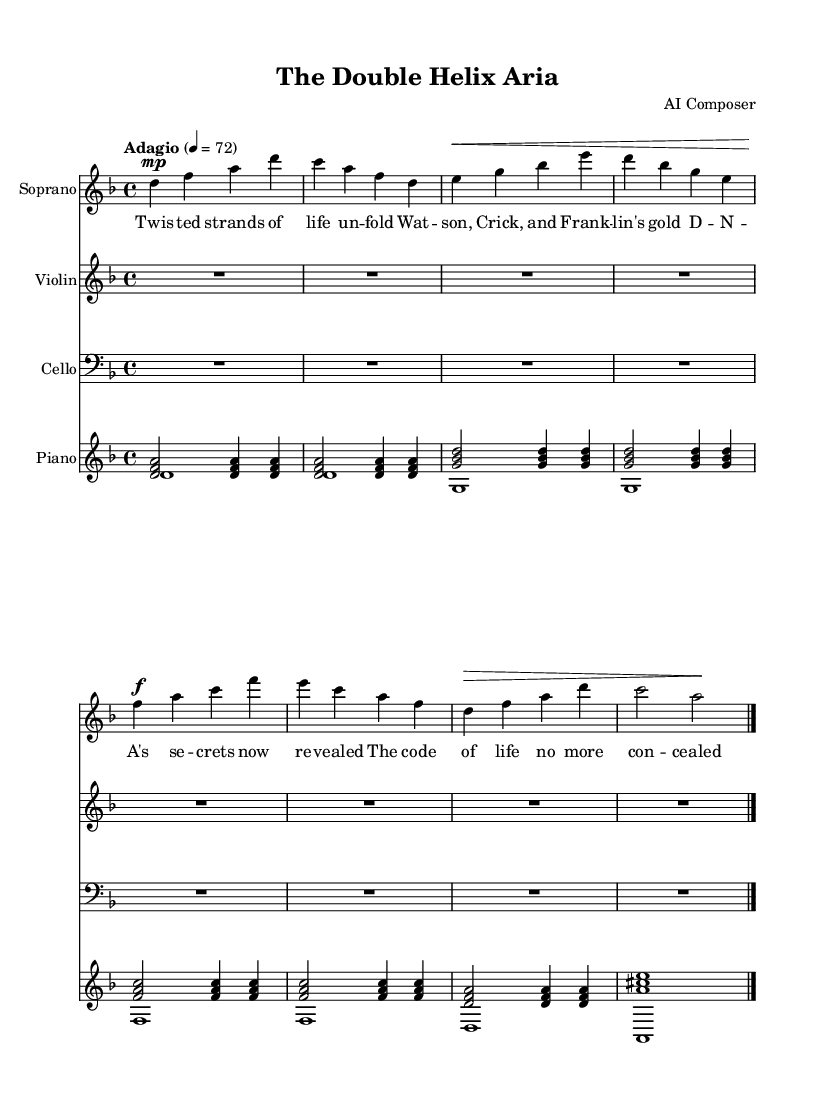What is the key signature of this music? The key signature indicates that the music is in D minor. This can be identified by looking for the key signature at the beginning of the staff, which shows one flat (B flat).
Answer: D minor What is the time signature of this music? The time signature is found at the beginning of the score, where it shows 4/4. This means there are four beats per measure and a quarter note gets one beat.
Answer: 4/4 What is the tempo marking for this piece? The tempo marking is indicated in the score as "Adagio," which suggests a slow and leisurely pace. This is further clarified by the metronome marking of 72 beats per minute.
Answer: Adagio How many measures are there in the soprano part? By counting the distinct measures in the soprano voice part, there are eight measures visible. This involves visually scanning the notation and counting the bar lines.
Answer: Eight What style of music does this piece represent? This piece is an opera, as indicated by its title "The Double Helix Aria" and the presence of a soprano voice with operatic lyrics, which typically express dramatic themes.
Answer: Opera Which notable figures are mentioned in the soprano lyrics? The lyrics reference Watson, Crick, and Franklin, who are famous for their contributions to the discovery of the DNA structure. By reading the lyrics, these names stand out as key figures in this context.
Answer: Watson, Crick, and Franklin 